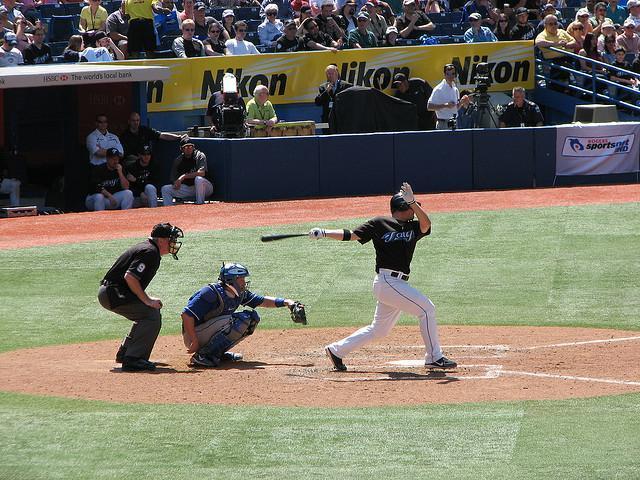How many people are in the photo?
Give a very brief answer. 6. How many cars have zebra stripes?
Give a very brief answer. 0. 